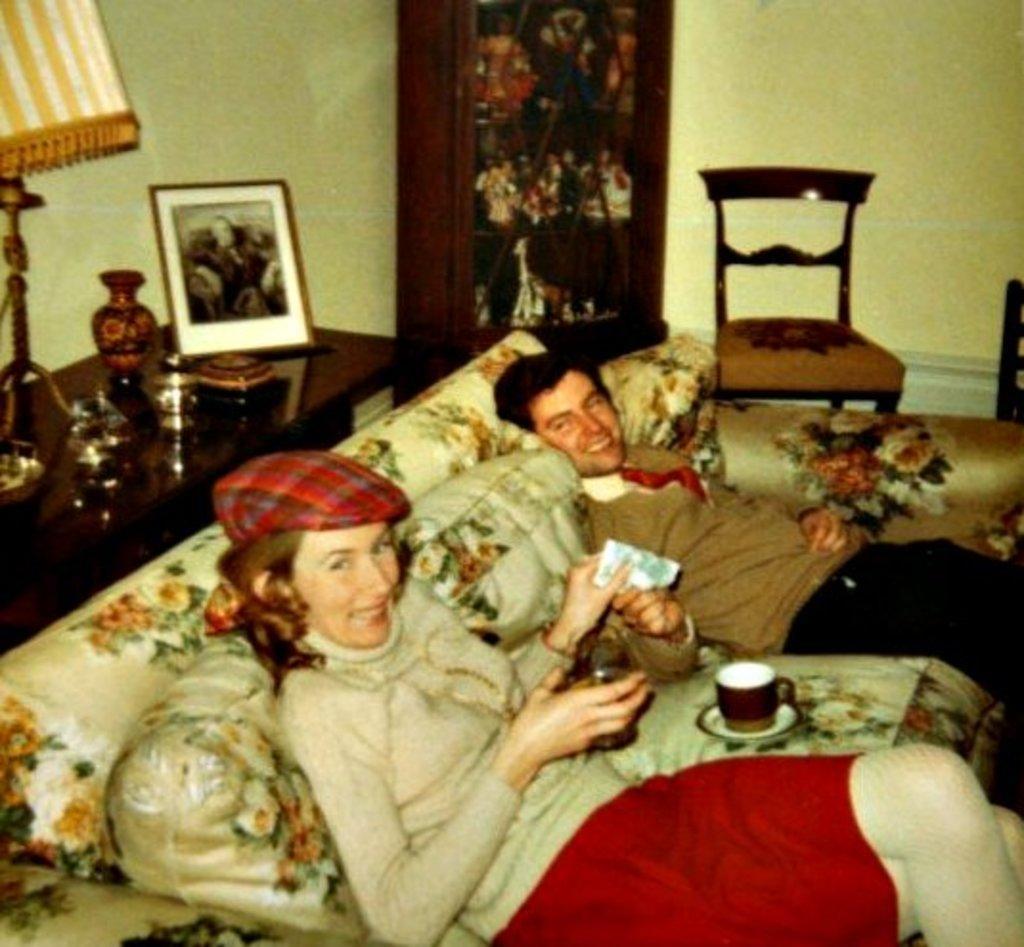Describe this image in one or two sentences. In this picture there is a man and a woman they both are sitting on a sofa and there is a chair at the right side of the image and there is a desk at the left side of the image with a photograph and a lamp, the woman and a man they both are holding a packet in their hands. 